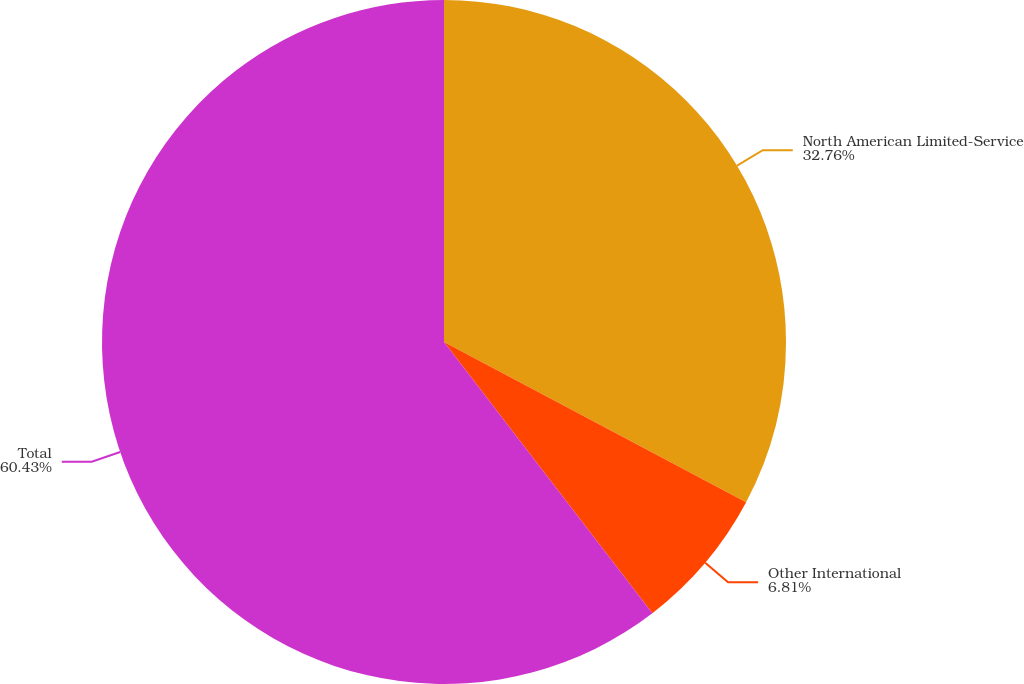Convert chart. <chart><loc_0><loc_0><loc_500><loc_500><pie_chart><fcel>North American Limited-Service<fcel>Other International<fcel>Total<nl><fcel>32.76%<fcel>6.81%<fcel>60.42%<nl></chart> 